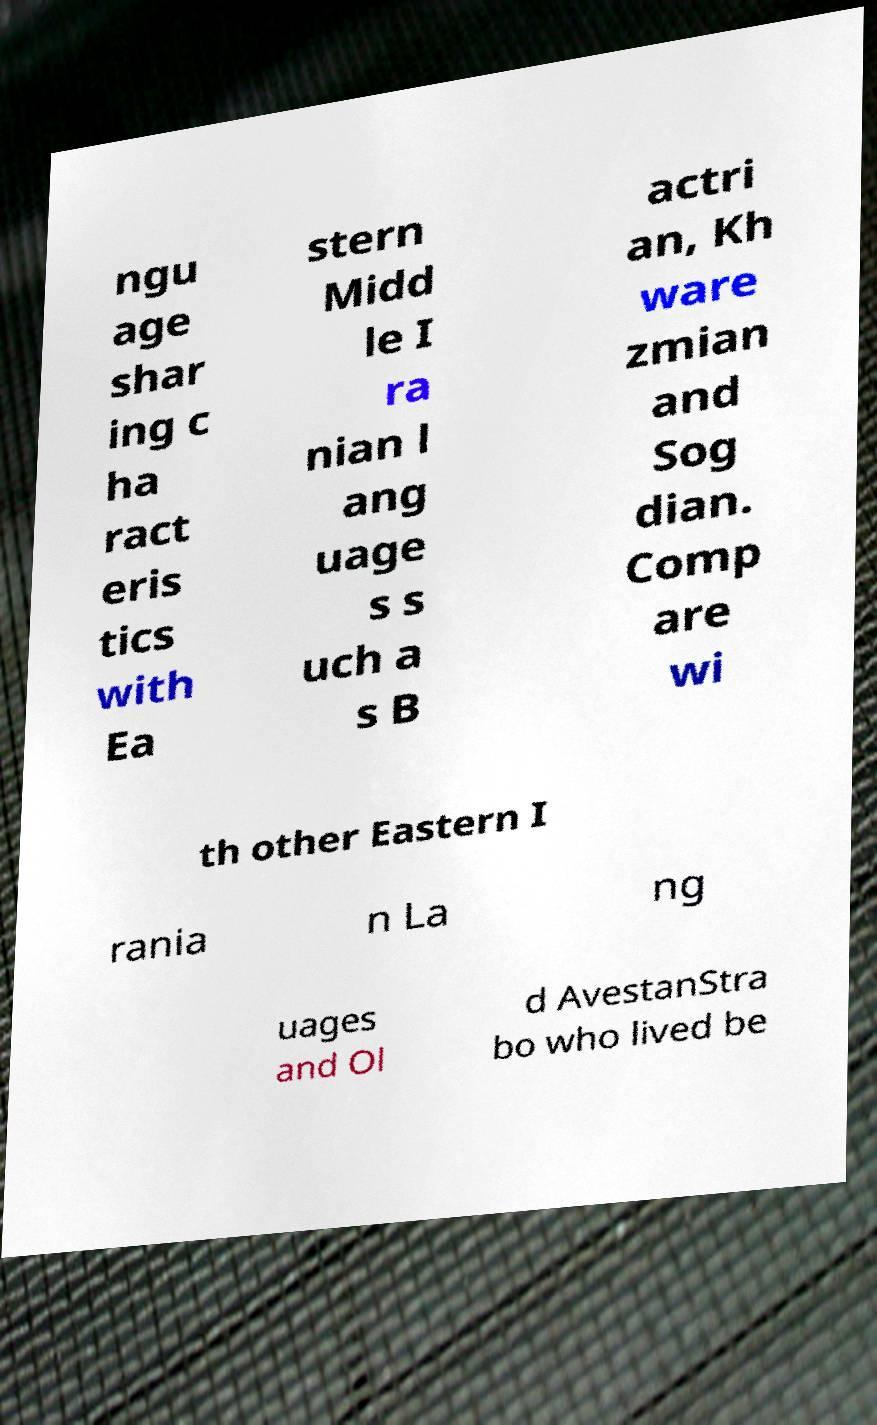Could you extract and type out the text from this image? ngu age shar ing c ha ract eris tics with Ea stern Midd le I ra nian l ang uage s s uch a s B actri an, Kh ware zmian and Sog dian. Comp are wi th other Eastern I rania n La ng uages and Ol d AvestanStra bo who lived be 